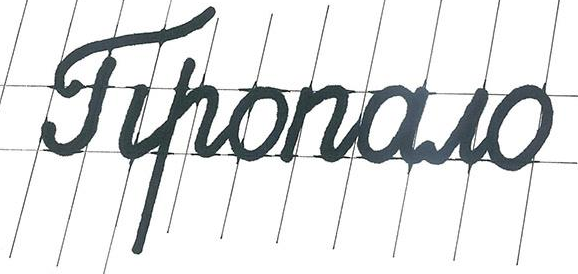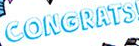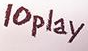Read the text content from these images in order, separated by a semicolon. Tiponowo; CONGRATS; 10play 